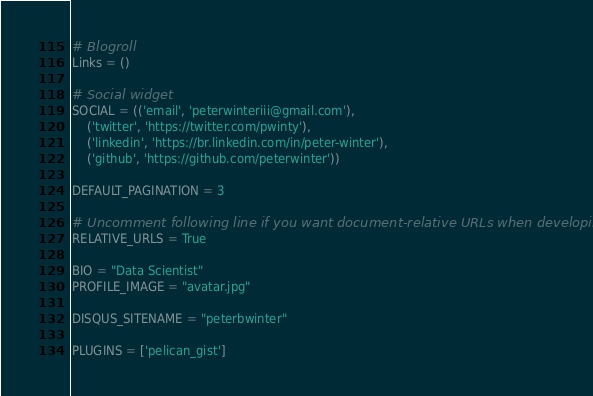Convert code to text. <code><loc_0><loc_0><loc_500><loc_500><_Python_>
# Blogroll
Links = ()

# Social widget
SOCIAL = (('email', 'peterwinteriii@gmail.com'),
    ('twitter', 'https://twitter.com/pwinty'),
    ('linkedin', 'https://br.linkedin.com/in/peter-winter'),
    ('github', 'https://github.com/peterwinter'))

DEFAULT_PAGINATION = 3

# Uncomment following line if you want document-relative URLs when developing
RELATIVE_URLS = True

BIO = "Data Scientist"
PROFILE_IMAGE = "avatar.jpg"

DISQUS_SITENAME = "peterbwinter"

PLUGINS = ['pelican_gist']
</code> 